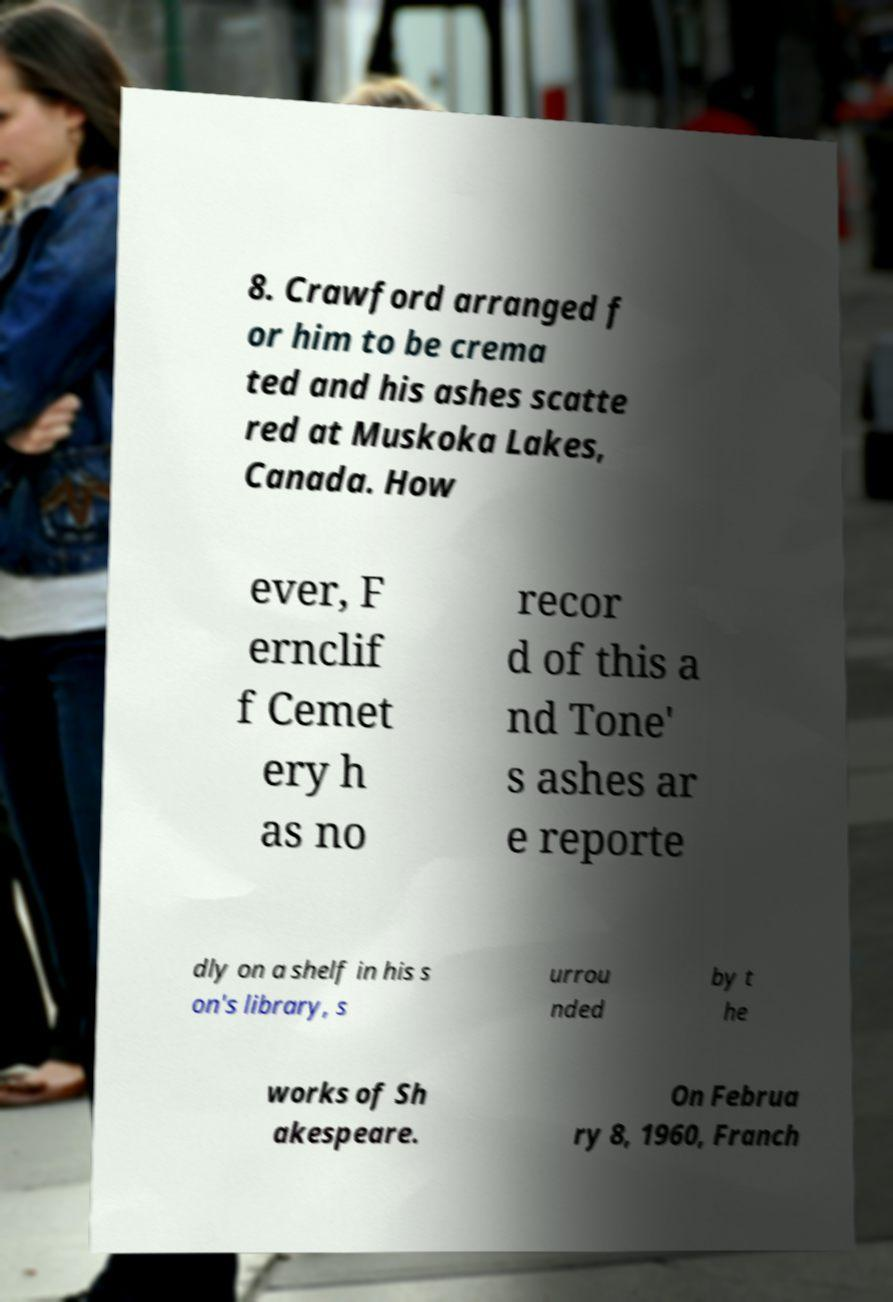For documentation purposes, I need the text within this image transcribed. Could you provide that? 8. Crawford arranged f or him to be crema ted and his ashes scatte red at Muskoka Lakes, Canada. How ever, F ernclif f Cemet ery h as no recor d of this a nd Tone' s ashes ar e reporte dly on a shelf in his s on's library, s urrou nded by t he works of Sh akespeare. On Februa ry 8, 1960, Franch 